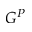<formula> <loc_0><loc_0><loc_500><loc_500>G ^ { P }</formula> 